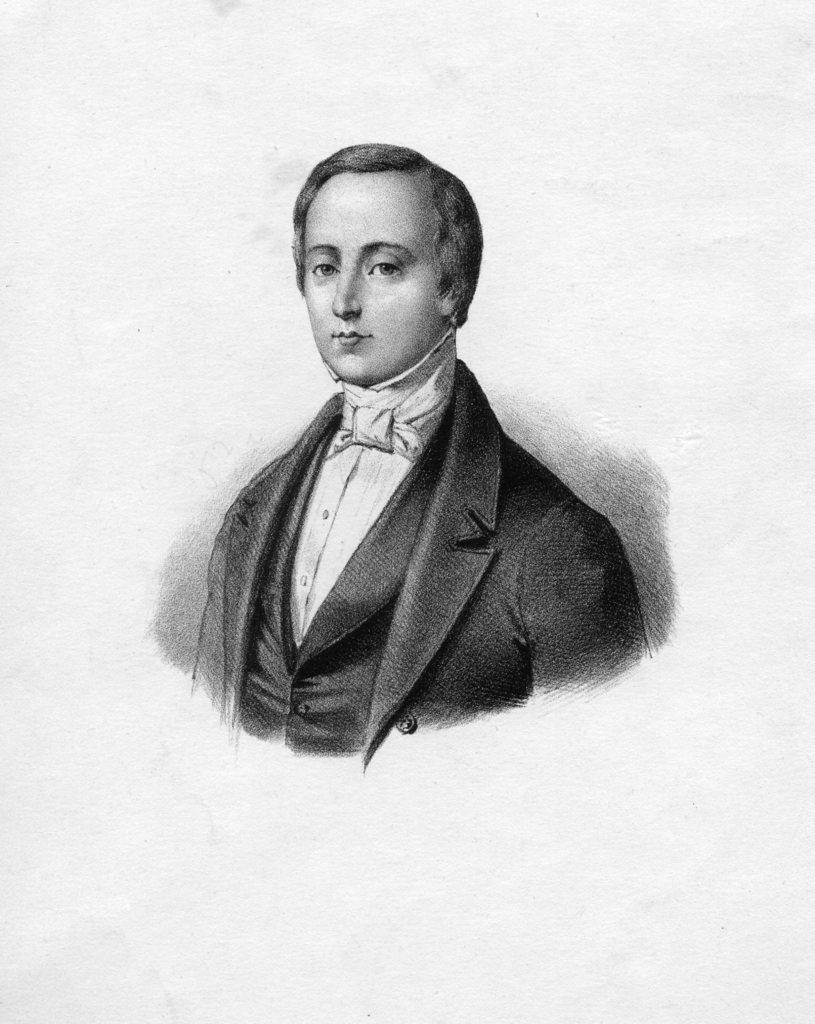What type of drawing is depicted in the image? The image is a pencil sketch of a person. What is the person in the sketch wearing? The person in the sketch is wearing a suit. What color is the background of the sketch? The background of the sketch is white. Can you tell me which language the person in the sketch is speaking? The image is a pencil sketch, so it does not depict any spoken language. 